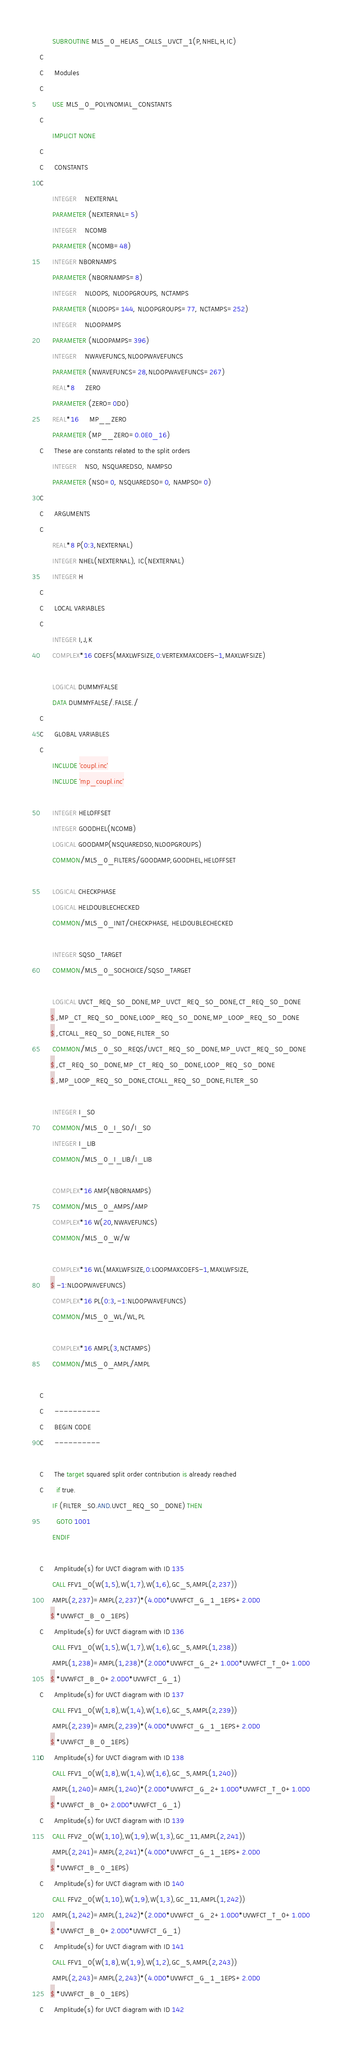<code> <loc_0><loc_0><loc_500><loc_500><_FORTRAN_>      SUBROUTINE ML5_0_HELAS_CALLS_UVCT_1(P,NHEL,H,IC)
C     
C     Modules
C     
      USE ML5_0_POLYNOMIAL_CONSTANTS
C     
      IMPLICIT NONE
C     
C     CONSTANTS
C     
      INTEGER    NEXTERNAL
      PARAMETER (NEXTERNAL=5)
      INTEGER    NCOMB
      PARAMETER (NCOMB=48)
      INTEGER NBORNAMPS
      PARAMETER (NBORNAMPS=8)
      INTEGER    NLOOPS, NLOOPGROUPS, NCTAMPS
      PARAMETER (NLOOPS=144, NLOOPGROUPS=77, NCTAMPS=252)
      INTEGER    NLOOPAMPS
      PARAMETER (NLOOPAMPS=396)
      INTEGER    NWAVEFUNCS,NLOOPWAVEFUNCS
      PARAMETER (NWAVEFUNCS=28,NLOOPWAVEFUNCS=267)
      REAL*8     ZERO
      PARAMETER (ZERO=0D0)
      REAL*16     MP__ZERO
      PARAMETER (MP__ZERO=0.0E0_16)
C     These are constants related to the split orders
      INTEGER    NSO, NSQUAREDSO, NAMPSO
      PARAMETER (NSO=0, NSQUAREDSO=0, NAMPSO=0)
C     
C     ARGUMENTS
C     
      REAL*8 P(0:3,NEXTERNAL)
      INTEGER NHEL(NEXTERNAL), IC(NEXTERNAL)
      INTEGER H
C     
C     LOCAL VARIABLES
C     
      INTEGER I,J,K
      COMPLEX*16 COEFS(MAXLWFSIZE,0:VERTEXMAXCOEFS-1,MAXLWFSIZE)

      LOGICAL DUMMYFALSE
      DATA DUMMYFALSE/.FALSE./
C     
C     GLOBAL VARIABLES
C     
      INCLUDE 'coupl.inc'
      INCLUDE 'mp_coupl.inc'

      INTEGER HELOFFSET
      INTEGER GOODHEL(NCOMB)
      LOGICAL GOODAMP(NSQUAREDSO,NLOOPGROUPS)
      COMMON/ML5_0_FILTERS/GOODAMP,GOODHEL,HELOFFSET

      LOGICAL CHECKPHASE
      LOGICAL HELDOUBLECHECKED
      COMMON/ML5_0_INIT/CHECKPHASE, HELDOUBLECHECKED

      INTEGER SQSO_TARGET
      COMMON/ML5_0_SOCHOICE/SQSO_TARGET

      LOGICAL UVCT_REQ_SO_DONE,MP_UVCT_REQ_SO_DONE,CT_REQ_SO_DONE
     $ ,MP_CT_REQ_SO_DONE,LOOP_REQ_SO_DONE,MP_LOOP_REQ_SO_DONE
     $ ,CTCALL_REQ_SO_DONE,FILTER_SO
      COMMON/ML5_0_SO_REQS/UVCT_REQ_SO_DONE,MP_UVCT_REQ_SO_DONE
     $ ,CT_REQ_SO_DONE,MP_CT_REQ_SO_DONE,LOOP_REQ_SO_DONE
     $ ,MP_LOOP_REQ_SO_DONE,CTCALL_REQ_SO_DONE,FILTER_SO

      INTEGER I_SO
      COMMON/ML5_0_I_SO/I_SO
      INTEGER I_LIB
      COMMON/ML5_0_I_LIB/I_LIB

      COMPLEX*16 AMP(NBORNAMPS)
      COMMON/ML5_0_AMPS/AMP
      COMPLEX*16 W(20,NWAVEFUNCS)
      COMMON/ML5_0_W/W

      COMPLEX*16 WL(MAXLWFSIZE,0:LOOPMAXCOEFS-1,MAXLWFSIZE,
     $ -1:NLOOPWAVEFUNCS)
      COMPLEX*16 PL(0:3,-1:NLOOPWAVEFUNCS)
      COMMON/ML5_0_WL/WL,PL

      COMPLEX*16 AMPL(3,NCTAMPS)
      COMMON/ML5_0_AMPL/AMPL

C     
C     ----------
C     BEGIN CODE
C     ----------

C     The target squared split order contribution is already reached
C      if true.
      IF (FILTER_SO.AND.UVCT_REQ_SO_DONE) THEN
        GOTO 1001
      ENDIF

C     Amplitude(s) for UVCT diagram with ID 135
      CALL FFV1_0(W(1,5),W(1,7),W(1,6),GC_5,AMPL(2,237))
      AMPL(2,237)=AMPL(2,237)*(4.0D0*UVWFCT_G_1_1EPS+2.0D0
     $ *UVWFCT_B_0_1EPS)
C     Amplitude(s) for UVCT diagram with ID 136
      CALL FFV1_0(W(1,5),W(1,7),W(1,6),GC_5,AMPL(1,238))
      AMPL(1,238)=AMPL(1,238)*(2.0D0*UVWFCT_G_2+1.0D0*UVWFCT_T_0+1.0D0
     $ *UVWFCT_B_0+2.0D0*UVWFCT_G_1)
C     Amplitude(s) for UVCT diagram with ID 137
      CALL FFV1_0(W(1,8),W(1,4),W(1,6),GC_5,AMPL(2,239))
      AMPL(2,239)=AMPL(2,239)*(4.0D0*UVWFCT_G_1_1EPS+2.0D0
     $ *UVWFCT_B_0_1EPS)
C     Amplitude(s) for UVCT diagram with ID 138
      CALL FFV1_0(W(1,8),W(1,4),W(1,6),GC_5,AMPL(1,240))
      AMPL(1,240)=AMPL(1,240)*(2.0D0*UVWFCT_G_2+1.0D0*UVWFCT_T_0+1.0D0
     $ *UVWFCT_B_0+2.0D0*UVWFCT_G_1)
C     Amplitude(s) for UVCT diagram with ID 139
      CALL FFV2_0(W(1,10),W(1,9),W(1,3),GC_11,AMPL(2,241))
      AMPL(2,241)=AMPL(2,241)*(4.0D0*UVWFCT_G_1_1EPS+2.0D0
     $ *UVWFCT_B_0_1EPS)
C     Amplitude(s) for UVCT diagram with ID 140
      CALL FFV2_0(W(1,10),W(1,9),W(1,3),GC_11,AMPL(1,242))
      AMPL(1,242)=AMPL(1,242)*(2.0D0*UVWFCT_G_2+1.0D0*UVWFCT_T_0+1.0D0
     $ *UVWFCT_B_0+2.0D0*UVWFCT_G_1)
C     Amplitude(s) for UVCT diagram with ID 141
      CALL FFV1_0(W(1,8),W(1,9),W(1,2),GC_5,AMPL(2,243))
      AMPL(2,243)=AMPL(2,243)*(4.0D0*UVWFCT_G_1_1EPS+2.0D0
     $ *UVWFCT_B_0_1EPS)
C     Amplitude(s) for UVCT diagram with ID 142</code> 